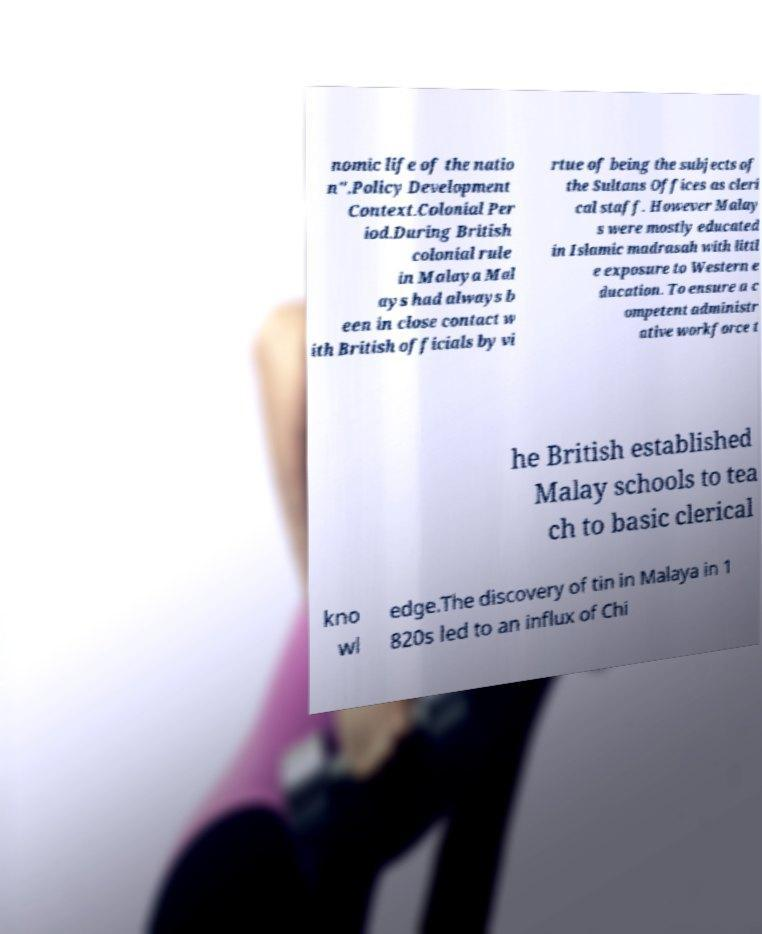Please identify and transcribe the text found in this image. nomic life of the natio n".Policy Development Context.Colonial Per iod.During British colonial rule in Malaya Mal ays had always b een in close contact w ith British officials by vi rtue of being the subjects of the Sultans Offices as cleri cal staff. However Malay s were mostly educated in Islamic madrasah with littl e exposure to Western e ducation. To ensure a c ompetent administr ative workforce t he British established Malay schools to tea ch to basic clerical kno wl edge.The discovery of tin in Malaya in 1 820s led to an influx of Chi 